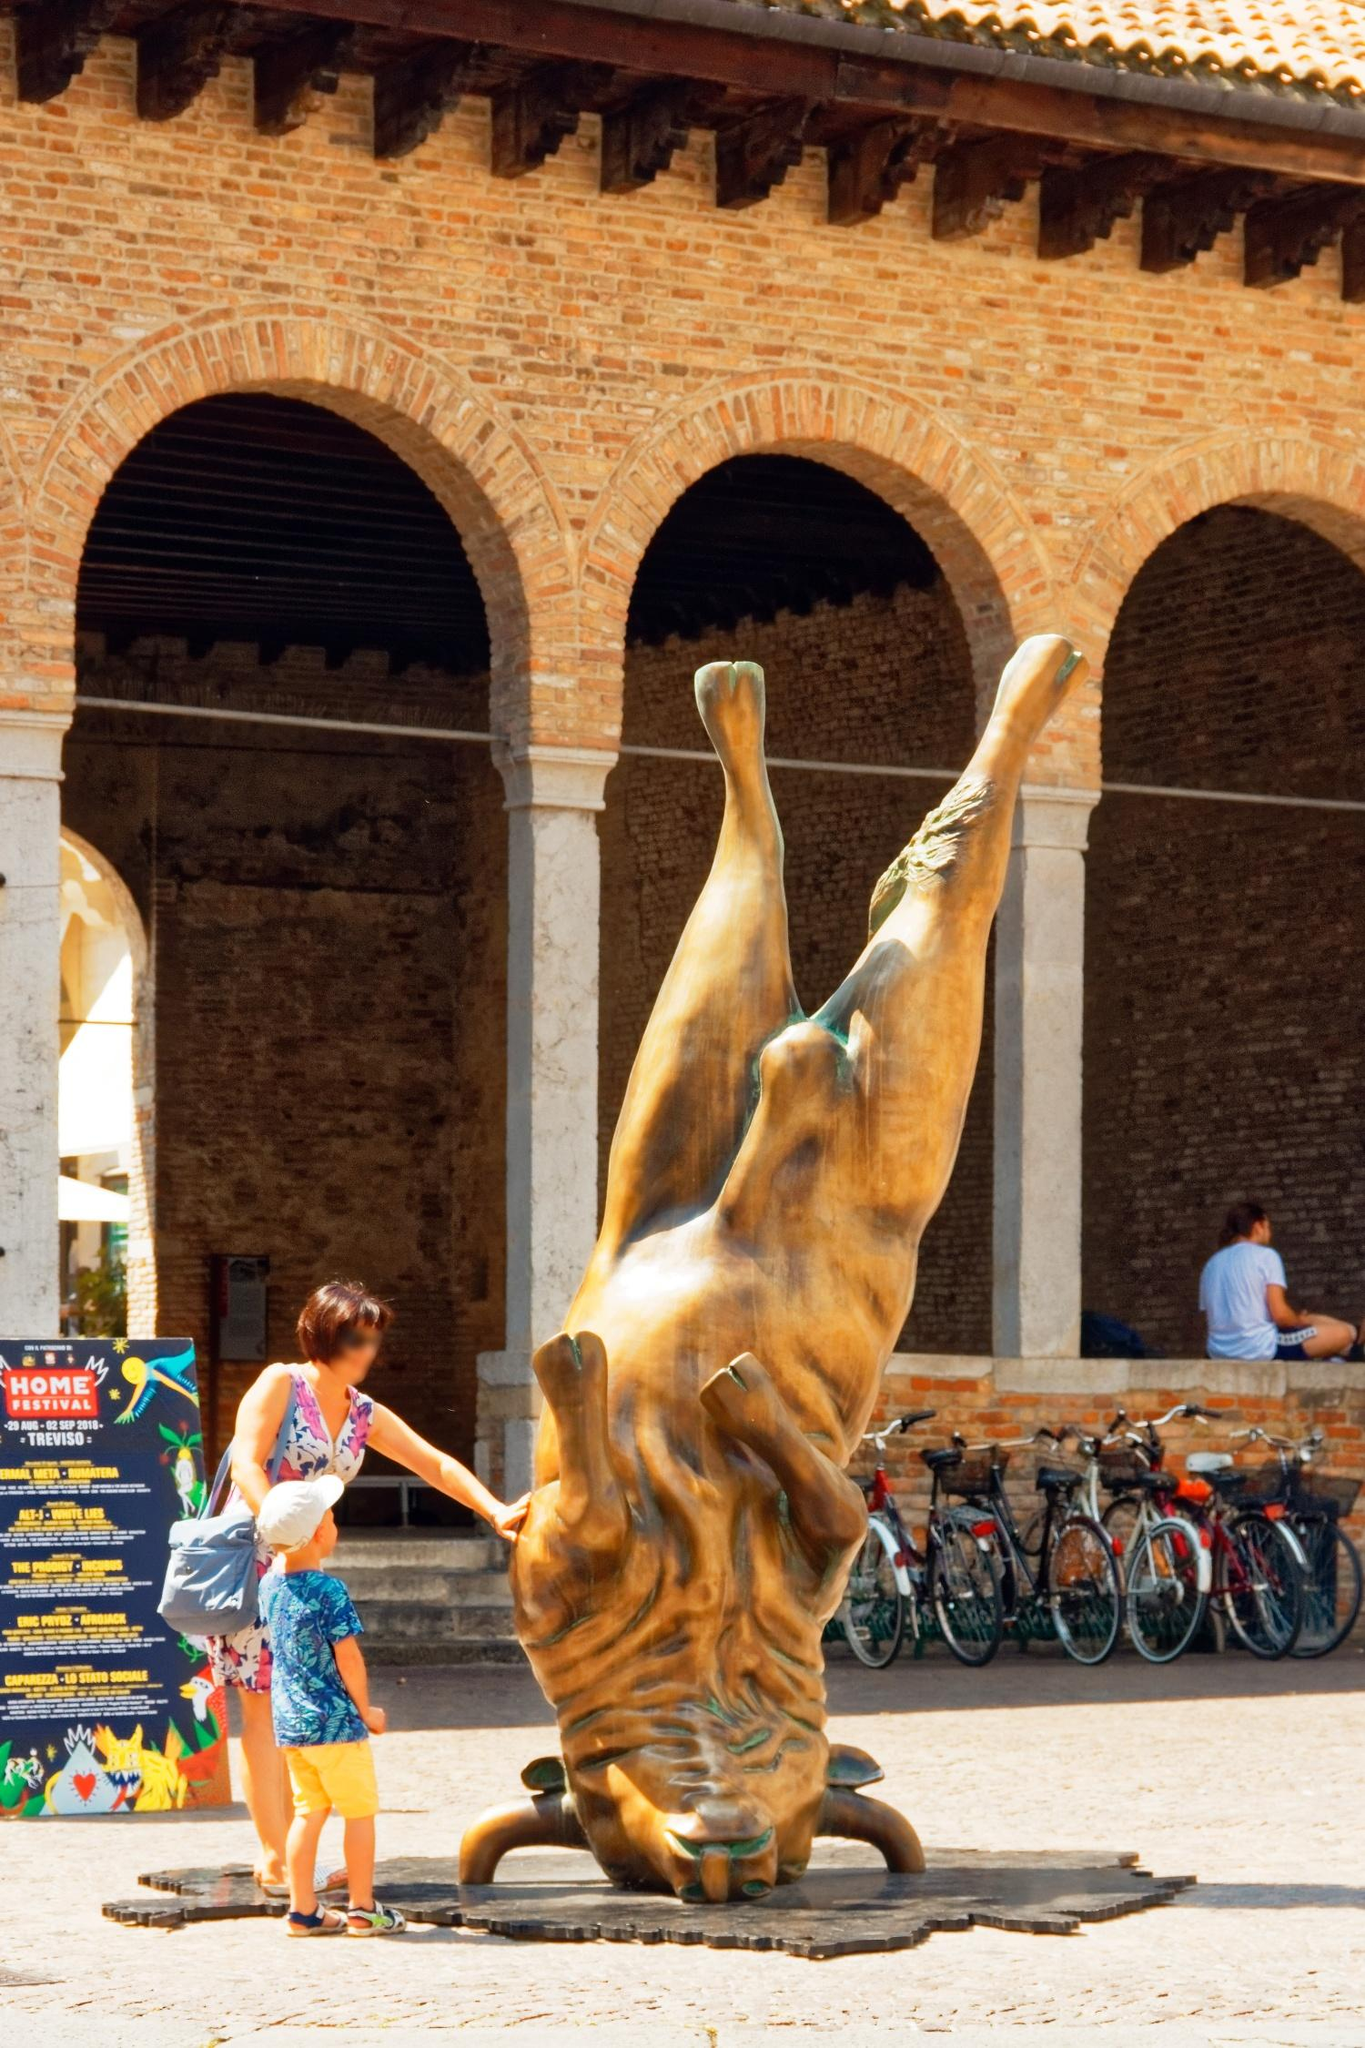Given the image, how would you describe the interaction between art and daily life? The image beautifully encapsulates the interaction between art and daily life, illustrating how seamlessly the two can coexist in a shared space. The bronze sculpture stands as a permanent artistic statement, yet it is not isolated from the flow of daily activities. People move around it, engage with it, and incorporate it into their day, making art a part of their everyday lives rather than an occasional encounter.

The bicycles parked along the wall, the sign of the 'HOME Festival', and the varied activities of individuals don't detach from the sculpture but rather weave it into the contemporary fabric of life in Milan. This interaction highlights the dynamism of public art, where an artistic piece in a communal space serves both as an object of beauty and contemplation and as a familiar fixture in people's routines.

Such a setting underscores the profound impact that art in public spaces can have, fostering a cultural dialogue and a sense of shared experience among all who pass by and interact with the piece. 